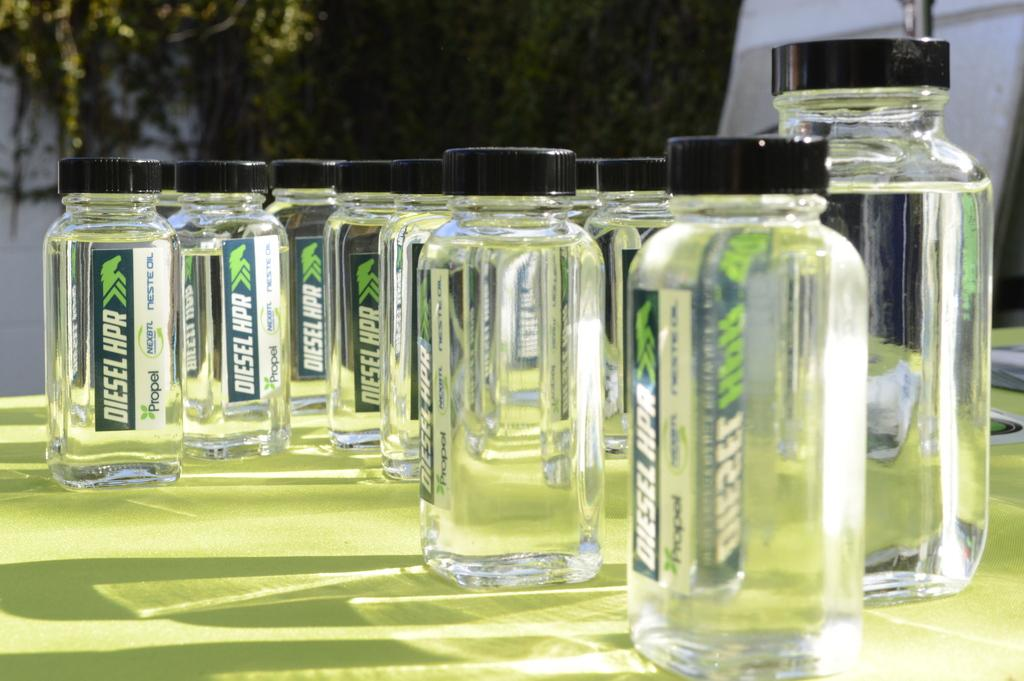<image>
Write a terse but informative summary of the picture. Small glass bottles have the Propel label on them. 